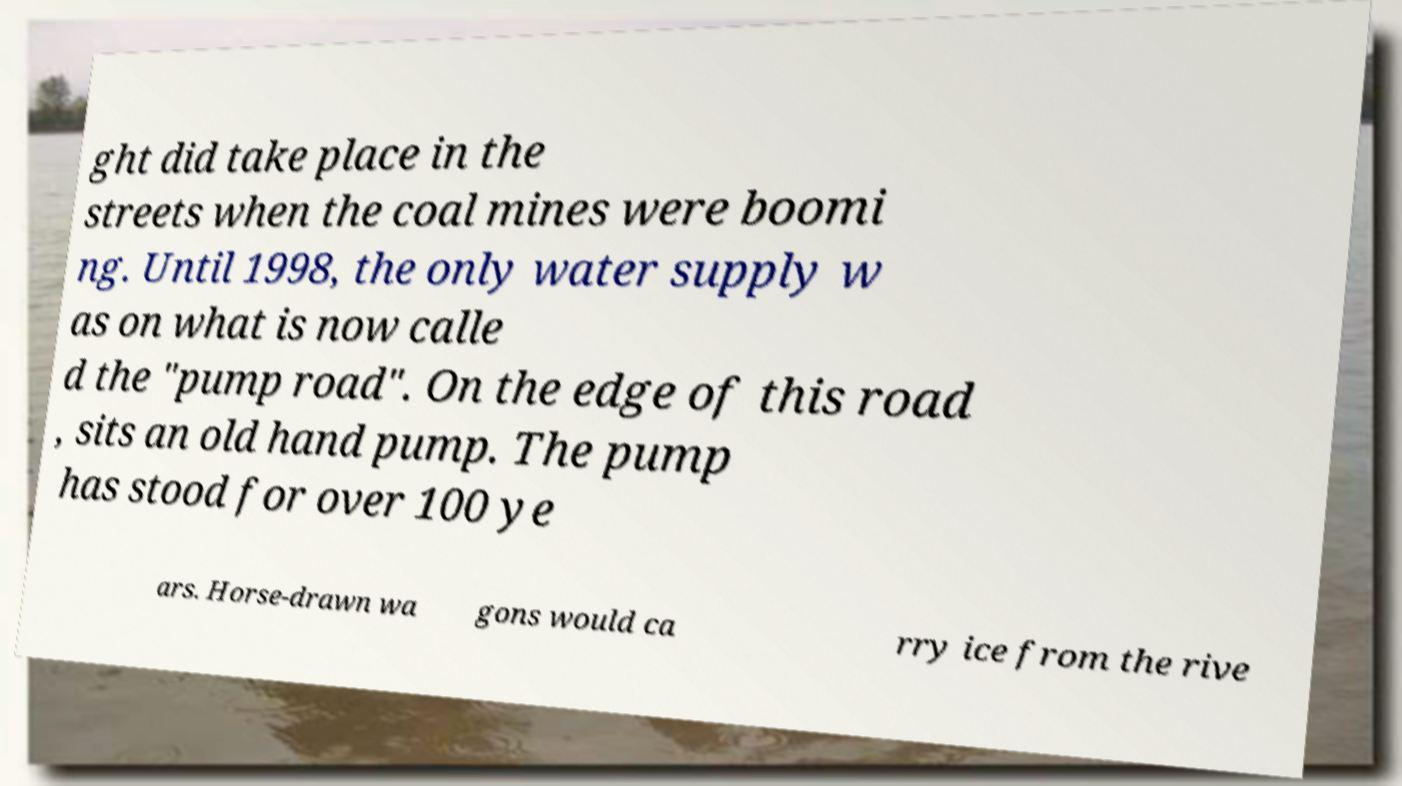Please identify and transcribe the text found in this image. ght did take place in the streets when the coal mines were boomi ng. Until 1998, the only water supply w as on what is now calle d the "pump road". On the edge of this road , sits an old hand pump. The pump has stood for over 100 ye ars. Horse-drawn wa gons would ca rry ice from the rive 